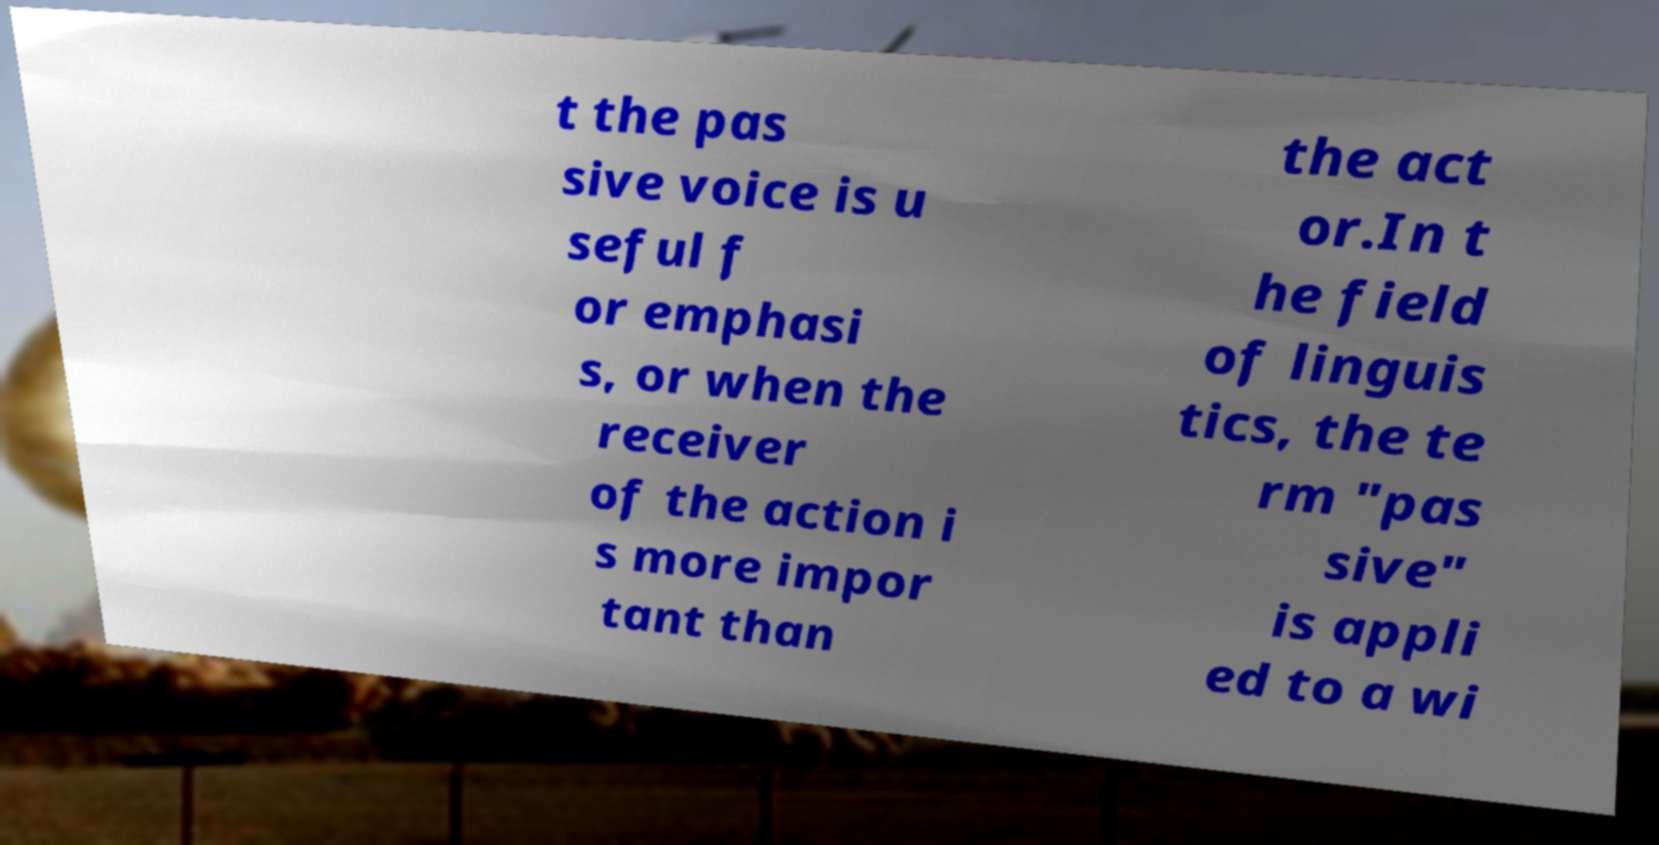Could you assist in decoding the text presented in this image and type it out clearly? t the pas sive voice is u seful f or emphasi s, or when the receiver of the action i s more impor tant than the act or.In t he field of linguis tics, the te rm "pas sive" is appli ed to a wi 